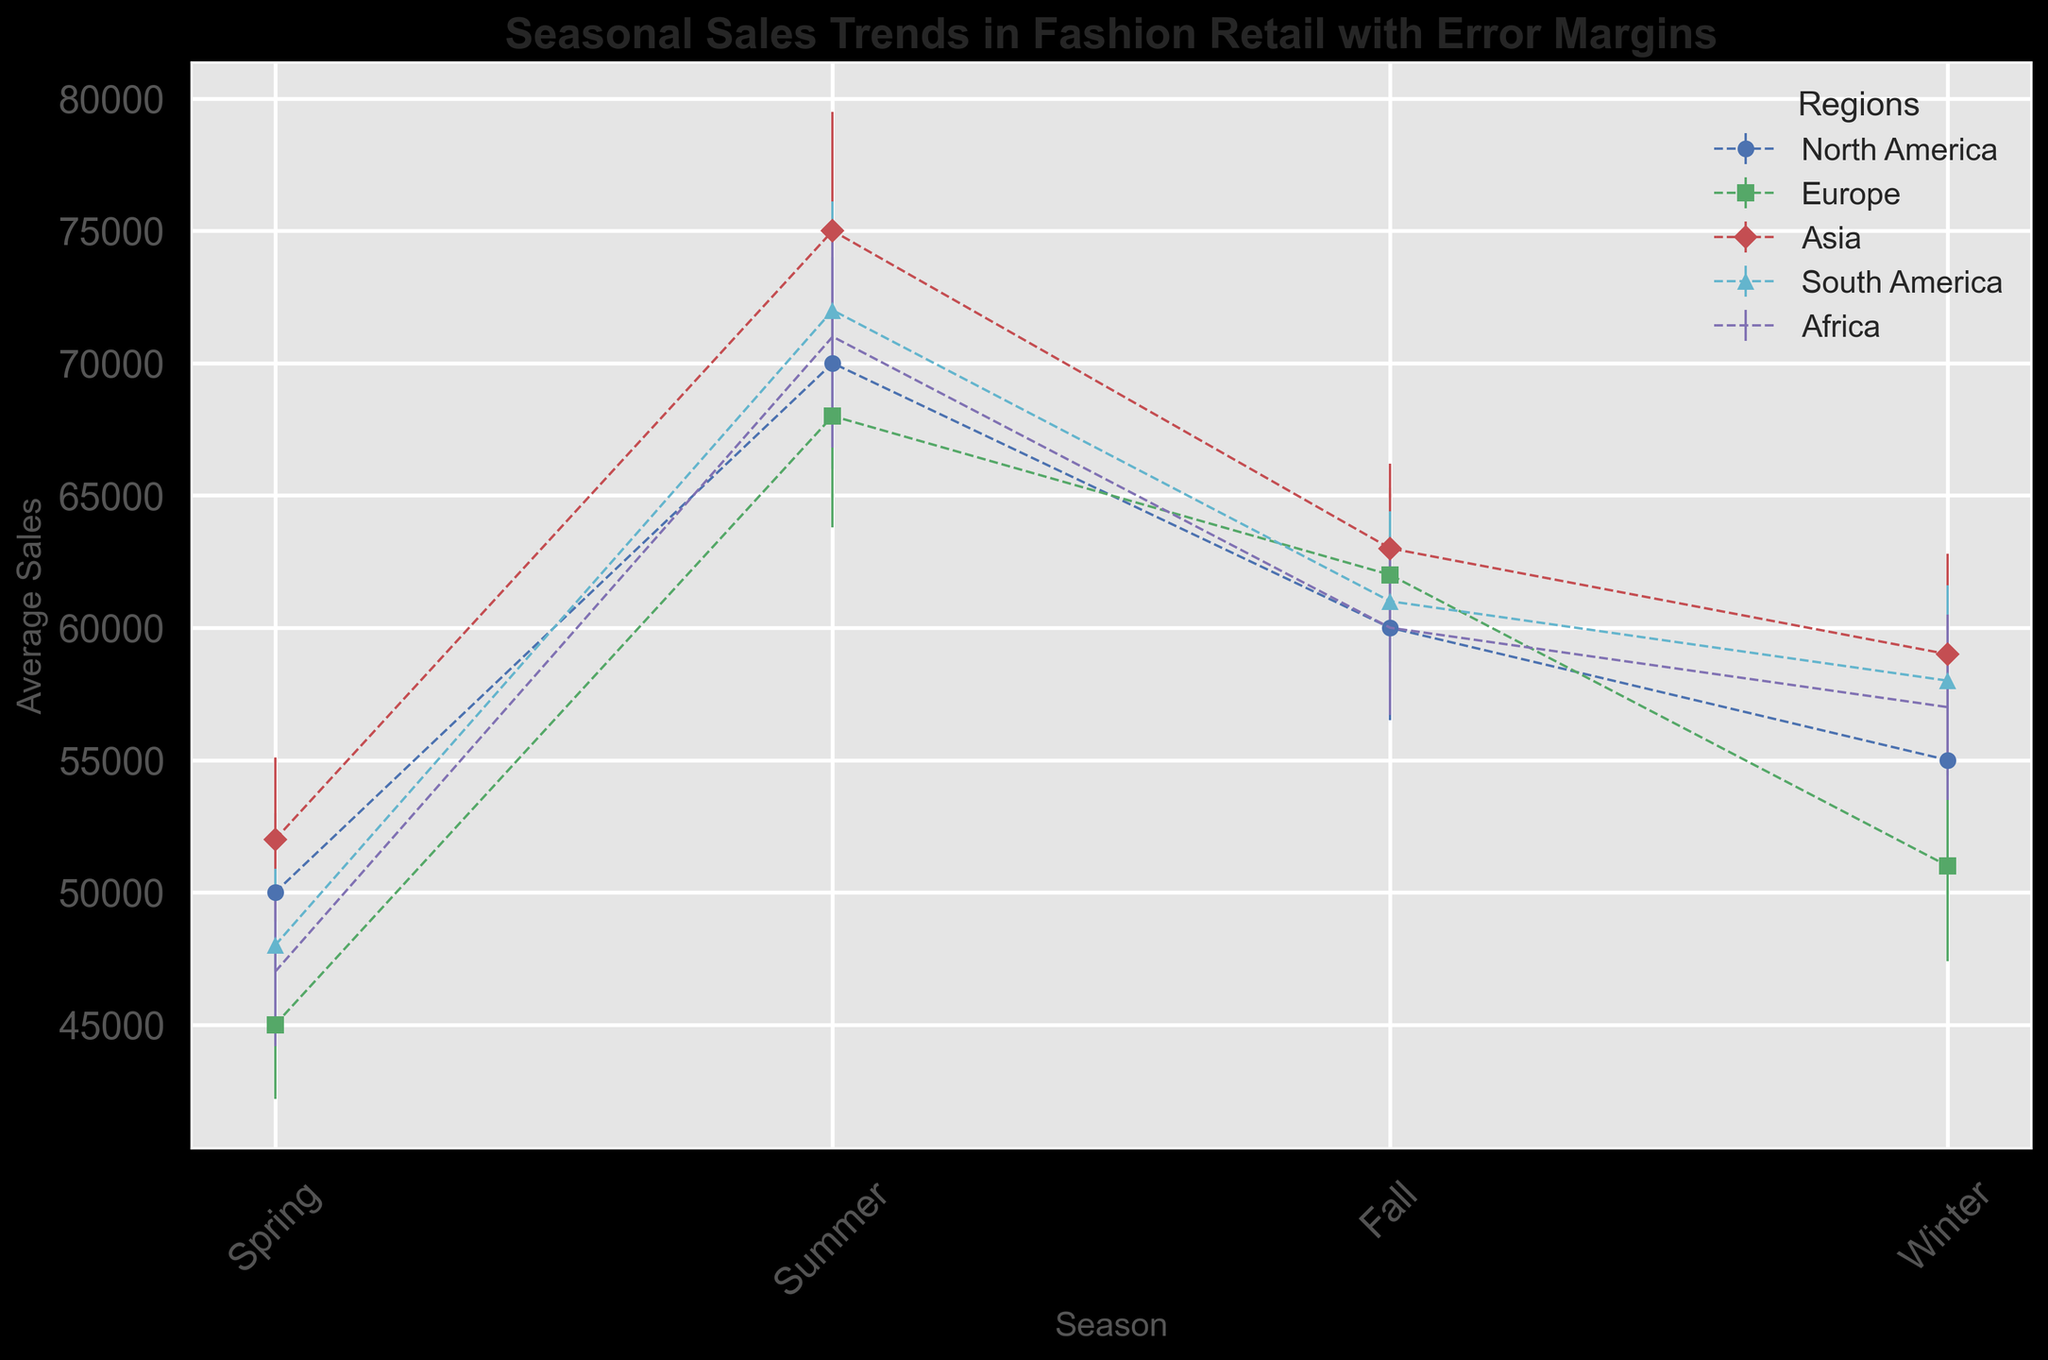What is the average sales for North America in Summer? To get the average sales for North America in Summer, look for the Summer sales data point for the North America region. According to the figure, the average sales for North America in Summer is 70,000.
Answer: 70,000 Which region has the highest average sales in Winter? Look at the Winter data points for all regions and find the one with the highest value. According to the figure, Asia has the highest average sales in Winter, which is 59,000.
Answer: Asia What is the difference between Europe's average sales in Fall and Spring? Subtract the average sales in Spring for Europe from the average sales in Fall for Europe. From the figure, Europe has 62,000 in Fall and 45,000 in Spring. Thus, 62,000 - 45,000 = 17,000.
Answer: 17,000 By how much do Asia’s average sales in Summer exceed those in Spring? To find the amount by which Asia's Summer sales exceed Spring sales, subtract the Spring sales from the Summer sales. The figure shows 75,000 for Summer and 52,000 for Spring. Therefore, 75,000 - 52,000 = 23,000.
Answer: 23,000 Which season has the lowest average sales for North America? Compare the average sales for all seasons in North America. According to the figure, North America has the lowest average sales in Spring, which is 50,000.
Answer: Spring Are South America's sales in Fall higher than Europe's sales in Winter? Compare South America's average sales in Fall to Europe's average sales in Winter. From the figure, South America has 61,000 in Fall, and Europe has 51,000 in Winter. So, yes, South America's sales in Fall are higher.
Answer: Yes Which region shows the narrowest error margin (smallest standard deviation) in any season? Identify the region and season with the smallest error margin in the figure. The smallest standard deviation is 2800 seen in Europe (Spring).
Answer: Europe, Spring What is the combined average sales of Asia and Africa in Summer? Add the average sales of both Asia and Africa in Summer. The figure shows 75,000 for Asia and 71,000 for Africa. Thus, 75,000 + 71,000 = 146,000.
Answer: 146,000 How does the average sales trend for Africa change from Spring to Summer? Compare the average sales in Spring and Summer for Africa. From the figure, the sales increase from 47,000 in Spring to 71,000 in Summer.
Answer: Increase What is the average seasonal sales for South America? Calculate the average of the seasonal sales values for South America. From the figure: (48,000 in Spring + 72,000 in Summer + 61,000 in Fall + 58,000 in Winter) / 4 = 239,000 / 4 = 59,750.
Answer: 59,750 